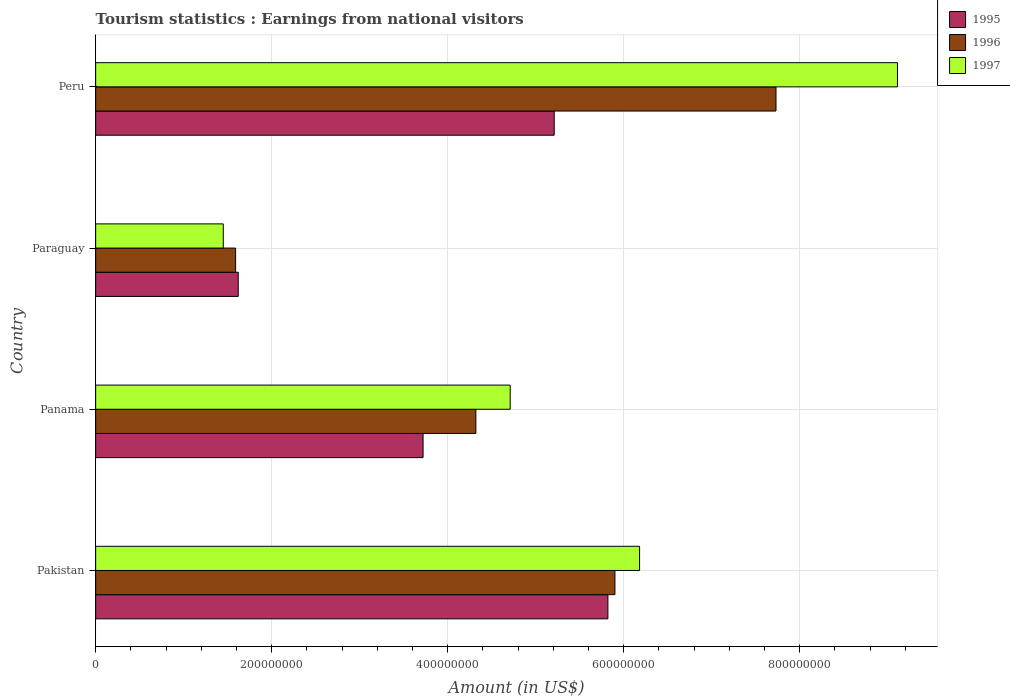How many different coloured bars are there?
Provide a short and direct response. 3. How many bars are there on the 3rd tick from the top?
Provide a short and direct response. 3. How many bars are there on the 3rd tick from the bottom?
Your response must be concise. 3. In how many cases, is the number of bars for a given country not equal to the number of legend labels?
Give a very brief answer. 0. What is the earnings from national visitors in 1997 in Pakistan?
Ensure brevity in your answer.  6.18e+08. Across all countries, what is the maximum earnings from national visitors in 1995?
Give a very brief answer. 5.82e+08. Across all countries, what is the minimum earnings from national visitors in 1995?
Your response must be concise. 1.62e+08. In which country was the earnings from national visitors in 1997 maximum?
Give a very brief answer. Peru. In which country was the earnings from national visitors in 1995 minimum?
Your response must be concise. Paraguay. What is the total earnings from national visitors in 1997 in the graph?
Make the answer very short. 2.14e+09. What is the difference between the earnings from national visitors in 1996 in Panama and that in Peru?
Your answer should be compact. -3.41e+08. What is the difference between the earnings from national visitors in 1996 in Pakistan and the earnings from national visitors in 1997 in Paraguay?
Ensure brevity in your answer.  4.45e+08. What is the average earnings from national visitors in 1997 per country?
Provide a short and direct response. 5.36e+08. What is the difference between the earnings from national visitors in 1995 and earnings from national visitors in 1997 in Pakistan?
Ensure brevity in your answer.  -3.60e+07. In how many countries, is the earnings from national visitors in 1995 greater than 800000000 US$?
Your answer should be very brief. 0. What is the ratio of the earnings from national visitors in 1995 in Pakistan to that in Paraguay?
Ensure brevity in your answer.  3.59. Is the difference between the earnings from national visitors in 1995 in Pakistan and Peru greater than the difference between the earnings from national visitors in 1997 in Pakistan and Peru?
Your answer should be compact. Yes. What is the difference between the highest and the second highest earnings from national visitors in 1996?
Your answer should be compact. 1.83e+08. What is the difference between the highest and the lowest earnings from national visitors in 1995?
Make the answer very short. 4.20e+08. What does the 2nd bar from the top in Paraguay represents?
Offer a very short reply. 1996. Is it the case that in every country, the sum of the earnings from national visitors in 1997 and earnings from national visitors in 1996 is greater than the earnings from national visitors in 1995?
Your answer should be very brief. Yes. Are all the bars in the graph horizontal?
Your answer should be very brief. Yes. What is the difference between two consecutive major ticks on the X-axis?
Provide a short and direct response. 2.00e+08. Does the graph contain grids?
Your answer should be very brief. Yes. How are the legend labels stacked?
Your response must be concise. Vertical. What is the title of the graph?
Make the answer very short. Tourism statistics : Earnings from national visitors. What is the label or title of the Y-axis?
Ensure brevity in your answer.  Country. What is the Amount (in US$) of 1995 in Pakistan?
Offer a very short reply. 5.82e+08. What is the Amount (in US$) of 1996 in Pakistan?
Your answer should be very brief. 5.90e+08. What is the Amount (in US$) of 1997 in Pakistan?
Your answer should be compact. 6.18e+08. What is the Amount (in US$) in 1995 in Panama?
Provide a succinct answer. 3.72e+08. What is the Amount (in US$) in 1996 in Panama?
Offer a very short reply. 4.32e+08. What is the Amount (in US$) in 1997 in Panama?
Offer a terse response. 4.71e+08. What is the Amount (in US$) of 1995 in Paraguay?
Your answer should be compact. 1.62e+08. What is the Amount (in US$) in 1996 in Paraguay?
Your answer should be very brief. 1.59e+08. What is the Amount (in US$) of 1997 in Paraguay?
Keep it short and to the point. 1.45e+08. What is the Amount (in US$) in 1995 in Peru?
Provide a succinct answer. 5.21e+08. What is the Amount (in US$) in 1996 in Peru?
Your answer should be compact. 7.73e+08. What is the Amount (in US$) in 1997 in Peru?
Your answer should be compact. 9.11e+08. Across all countries, what is the maximum Amount (in US$) in 1995?
Offer a terse response. 5.82e+08. Across all countries, what is the maximum Amount (in US$) of 1996?
Provide a succinct answer. 7.73e+08. Across all countries, what is the maximum Amount (in US$) of 1997?
Ensure brevity in your answer.  9.11e+08. Across all countries, what is the minimum Amount (in US$) of 1995?
Provide a succinct answer. 1.62e+08. Across all countries, what is the minimum Amount (in US$) of 1996?
Your response must be concise. 1.59e+08. Across all countries, what is the minimum Amount (in US$) of 1997?
Give a very brief answer. 1.45e+08. What is the total Amount (in US$) of 1995 in the graph?
Your answer should be very brief. 1.64e+09. What is the total Amount (in US$) in 1996 in the graph?
Ensure brevity in your answer.  1.95e+09. What is the total Amount (in US$) of 1997 in the graph?
Provide a succinct answer. 2.14e+09. What is the difference between the Amount (in US$) in 1995 in Pakistan and that in Panama?
Make the answer very short. 2.10e+08. What is the difference between the Amount (in US$) in 1996 in Pakistan and that in Panama?
Make the answer very short. 1.58e+08. What is the difference between the Amount (in US$) of 1997 in Pakistan and that in Panama?
Give a very brief answer. 1.47e+08. What is the difference between the Amount (in US$) of 1995 in Pakistan and that in Paraguay?
Provide a succinct answer. 4.20e+08. What is the difference between the Amount (in US$) in 1996 in Pakistan and that in Paraguay?
Provide a short and direct response. 4.31e+08. What is the difference between the Amount (in US$) of 1997 in Pakistan and that in Paraguay?
Your answer should be very brief. 4.73e+08. What is the difference between the Amount (in US$) in 1995 in Pakistan and that in Peru?
Offer a very short reply. 6.10e+07. What is the difference between the Amount (in US$) of 1996 in Pakistan and that in Peru?
Offer a terse response. -1.83e+08. What is the difference between the Amount (in US$) in 1997 in Pakistan and that in Peru?
Your answer should be compact. -2.93e+08. What is the difference between the Amount (in US$) in 1995 in Panama and that in Paraguay?
Provide a succinct answer. 2.10e+08. What is the difference between the Amount (in US$) in 1996 in Panama and that in Paraguay?
Provide a short and direct response. 2.73e+08. What is the difference between the Amount (in US$) in 1997 in Panama and that in Paraguay?
Your answer should be compact. 3.26e+08. What is the difference between the Amount (in US$) in 1995 in Panama and that in Peru?
Provide a succinct answer. -1.49e+08. What is the difference between the Amount (in US$) of 1996 in Panama and that in Peru?
Your answer should be compact. -3.41e+08. What is the difference between the Amount (in US$) of 1997 in Panama and that in Peru?
Offer a very short reply. -4.40e+08. What is the difference between the Amount (in US$) of 1995 in Paraguay and that in Peru?
Offer a terse response. -3.59e+08. What is the difference between the Amount (in US$) of 1996 in Paraguay and that in Peru?
Offer a terse response. -6.14e+08. What is the difference between the Amount (in US$) in 1997 in Paraguay and that in Peru?
Offer a very short reply. -7.66e+08. What is the difference between the Amount (in US$) of 1995 in Pakistan and the Amount (in US$) of 1996 in Panama?
Your response must be concise. 1.50e+08. What is the difference between the Amount (in US$) in 1995 in Pakistan and the Amount (in US$) in 1997 in Panama?
Provide a short and direct response. 1.11e+08. What is the difference between the Amount (in US$) in 1996 in Pakistan and the Amount (in US$) in 1997 in Panama?
Provide a succinct answer. 1.19e+08. What is the difference between the Amount (in US$) in 1995 in Pakistan and the Amount (in US$) in 1996 in Paraguay?
Make the answer very short. 4.23e+08. What is the difference between the Amount (in US$) in 1995 in Pakistan and the Amount (in US$) in 1997 in Paraguay?
Give a very brief answer. 4.37e+08. What is the difference between the Amount (in US$) of 1996 in Pakistan and the Amount (in US$) of 1997 in Paraguay?
Give a very brief answer. 4.45e+08. What is the difference between the Amount (in US$) of 1995 in Pakistan and the Amount (in US$) of 1996 in Peru?
Provide a succinct answer. -1.91e+08. What is the difference between the Amount (in US$) in 1995 in Pakistan and the Amount (in US$) in 1997 in Peru?
Ensure brevity in your answer.  -3.29e+08. What is the difference between the Amount (in US$) in 1996 in Pakistan and the Amount (in US$) in 1997 in Peru?
Ensure brevity in your answer.  -3.21e+08. What is the difference between the Amount (in US$) of 1995 in Panama and the Amount (in US$) of 1996 in Paraguay?
Ensure brevity in your answer.  2.13e+08. What is the difference between the Amount (in US$) in 1995 in Panama and the Amount (in US$) in 1997 in Paraguay?
Your response must be concise. 2.27e+08. What is the difference between the Amount (in US$) of 1996 in Panama and the Amount (in US$) of 1997 in Paraguay?
Your answer should be compact. 2.87e+08. What is the difference between the Amount (in US$) in 1995 in Panama and the Amount (in US$) in 1996 in Peru?
Offer a terse response. -4.01e+08. What is the difference between the Amount (in US$) in 1995 in Panama and the Amount (in US$) in 1997 in Peru?
Provide a succinct answer. -5.39e+08. What is the difference between the Amount (in US$) in 1996 in Panama and the Amount (in US$) in 1997 in Peru?
Your response must be concise. -4.79e+08. What is the difference between the Amount (in US$) in 1995 in Paraguay and the Amount (in US$) in 1996 in Peru?
Give a very brief answer. -6.11e+08. What is the difference between the Amount (in US$) in 1995 in Paraguay and the Amount (in US$) in 1997 in Peru?
Your response must be concise. -7.49e+08. What is the difference between the Amount (in US$) of 1996 in Paraguay and the Amount (in US$) of 1997 in Peru?
Your answer should be very brief. -7.52e+08. What is the average Amount (in US$) of 1995 per country?
Provide a succinct answer. 4.09e+08. What is the average Amount (in US$) in 1996 per country?
Make the answer very short. 4.88e+08. What is the average Amount (in US$) in 1997 per country?
Your answer should be very brief. 5.36e+08. What is the difference between the Amount (in US$) in 1995 and Amount (in US$) in 1996 in Pakistan?
Give a very brief answer. -8.00e+06. What is the difference between the Amount (in US$) of 1995 and Amount (in US$) of 1997 in Pakistan?
Your answer should be compact. -3.60e+07. What is the difference between the Amount (in US$) in 1996 and Amount (in US$) in 1997 in Pakistan?
Make the answer very short. -2.80e+07. What is the difference between the Amount (in US$) in 1995 and Amount (in US$) in 1996 in Panama?
Ensure brevity in your answer.  -6.00e+07. What is the difference between the Amount (in US$) in 1995 and Amount (in US$) in 1997 in Panama?
Keep it short and to the point. -9.90e+07. What is the difference between the Amount (in US$) of 1996 and Amount (in US$) of 1997 in Panama?
Your answer should be compact. -3.90e+07. What is the difference between the Amount (in US$) of 1995 and Amount (in US$) of 1997 in Paraguay?
Provide a succinct answer. 1.70e+07. What is the difference between the Amount (in US$) in 1996 and Amount (in US$) in 1997 in Paraguay?
Provide a short and direct response. 1.40e+07. What is the difference between the Amount (in US$) of 1995 and Amount (in US$) of 1996 in Peru?
Make the answer very short. -2.52e+08. What is the difference between the Amount (in US$) of 1995 and Amount (in US$) of 1997 in Peru?
Ensure brevity in your answer.  -3.90e+08. What is the difference between the Amount (in US$) in 1996 and Amount (in US$) in 1997 in Peru?
Make the answer very short. -1.38e+08. What is the ratio of the Amount (in US$) in 1995 in Pakistan to that in Panama?
Provide a short and direct response. 1.56. What is the ratio of the Amount (in US$) in 1996 in Pakistan to that in Panama?
Provide a succinct answer. 1.37. What is the ratio of the Amount (in US$) of 1997 in Pakistan to that in Panama?
Offer a terse response. 1.31. What is the ratio of the Amount (in US$) of 1995 in Pakistan to that in Paraguay?
Keep it short and to the point. 3.59. What is the ratio of the Amount (in US$) in 1996 in Pakistan to that in Paraguay?
Give a very brief answer. 3.71. What is the ratio of the Amount (in US$) in 1997 in Pakistan to that in Paraguay?
Keep it short and to the point. 4.26. What is the ratio of the Amount (in US$) of 1995 in Pakistan to that in Peru?
Offer a very short reply. 1.12. What is the ratio of the Amount (in US$) in 1996 in Pakistan to that in Peru?
Your response must be concise. 0.76. What is the ratio of the Amount (in US$) in 1997 in Pakistan to that in Peru?
Keep it short and to the point. 0.68. What is the ratio of the Amount (in US$) in 1995 in Panama to that in Paraguay?
Your answer should be very brief. 2.3. What is the ratio of the Amount (in US$) of 1996 in Panama to that in Paraguay?
Give a very brief answer. 2.72. What is the ratio of the Amount (in US$) of 1997 in Panama to that in Paraguay?
Your answer should be very brief. 3.25. What is the ratio of the Amount (in US$) of 1995 in Panama to that in Peru?
Provide a succinct answer. 0.71. What is the ratio of the Amount (in US$) of 1996 in Panama to that in Peru?
Keep it short and to the point. 0.56. What is the ratio of the Amount (in US$) of 1997 in Panama to that in Peru?
Provide a short and direct response. 0.52. What is the ratio of the Amount (in US$) in 1995 in Paraguay to that in Peru?
Your response must be concise. 0.31. What is the ratio of the Amount (in US$) of 1996 in Paraguay to that in Peru?
Ensure brevity in your answer.  0.21. What is the ratio of the Amount (in US$) of 1997 in Paraguay to that in Peru?
Make the answer very short. 0.16. What is the difference between the highest and the second highest Amount (in US$) in 1995?
Ensure brevity in your answer.  6.10e+07. What is the difference between the highest and the second highest Amount (in US$) of 1996?
Ensure brevity in your answer.  1.83e+08. What is the difference between the highest and the second highest Amount (in US$) of 1997?
Provide a short and direct response. 2.93e+08. What is the difference between the highest and the lowest Amount (in US$) in 1995?
Your response must be concise. 4.20e+08. What is the difference between the highest and the lowest Amount (in US$) of 1996?
Provide a succinct answer. 6.14e+08. What is the difference between the highest and the lowest Amount (in US$) of 1997?
Provide a short and direct response. 7.66e+08. 